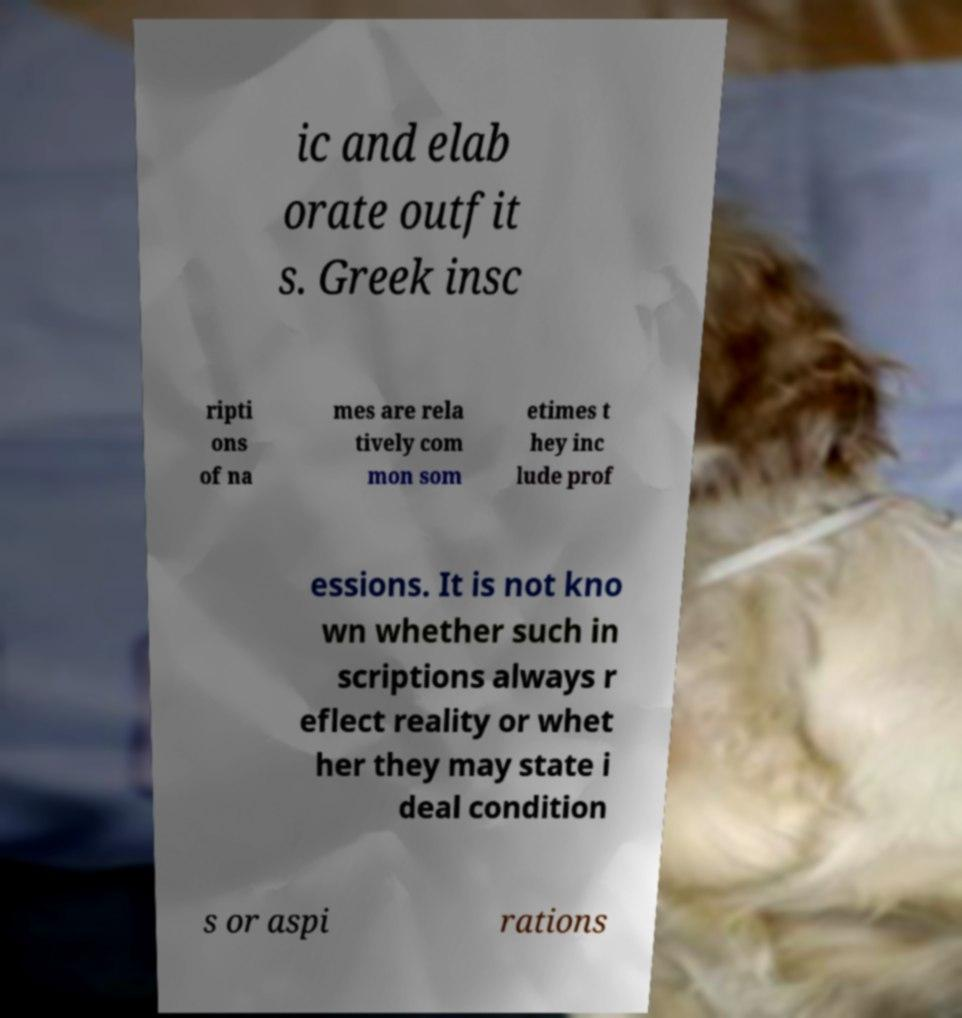What messages or text are displayed in this image? I need them in a readable, typed format. ic and elab orate outfit s. Greek insc ripti ons of na mes are rela tively com mon som etimes t hey inc lude prof essions. It is not kno wn whether such in scriptions always r eflect reality or whet her they may state i deal condition s or aspi rations 